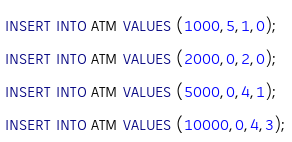Convert code to text. <code><loc_0><loc_0><loc_500><loc_500><_SQL_>INSERT INTO ATM VALUES (1000,5,1,0);
INSERT INTO ATM VALUES (2000,0,2,0);
INSERT INTO ATM VALUES (5000,0,4,1);
INSERT INTO ATM VALUES (10000,0,4,3);</code> 